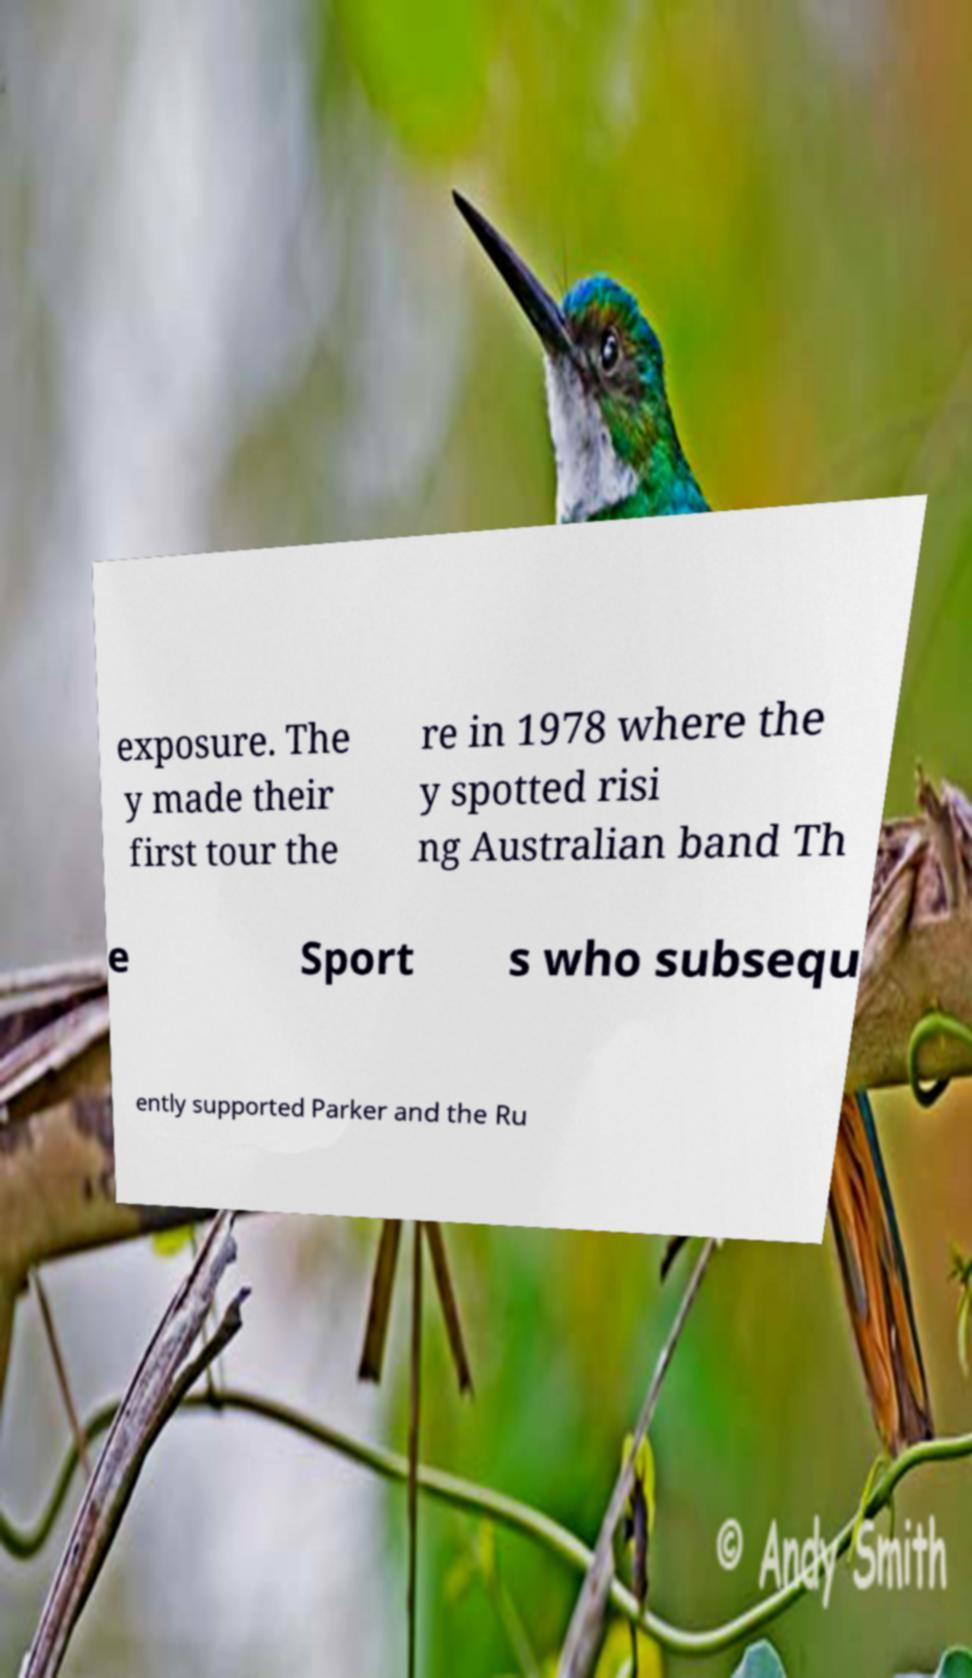Can you read and provide the text displayed in the image?This photo seems to have some interesting text. Can you extract and type it out for me? exposure. The y made their first tour the re in 1978 where the y spotted risi ng Australian band Th e Sport s who subsequ ently supported Parker and the Ru 